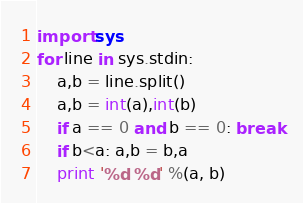Convert code to text. <code><loc_0><loc_0><loc_500><loc_500><_Python_>import sys
for line in sys.stdin:
    a,b = line.split()
    a,b = int(a),int(b)
    if a == 0 and b == 0: break
    if b<a: a,b = b,a
    print '%d %d' %(a, b)</code> 